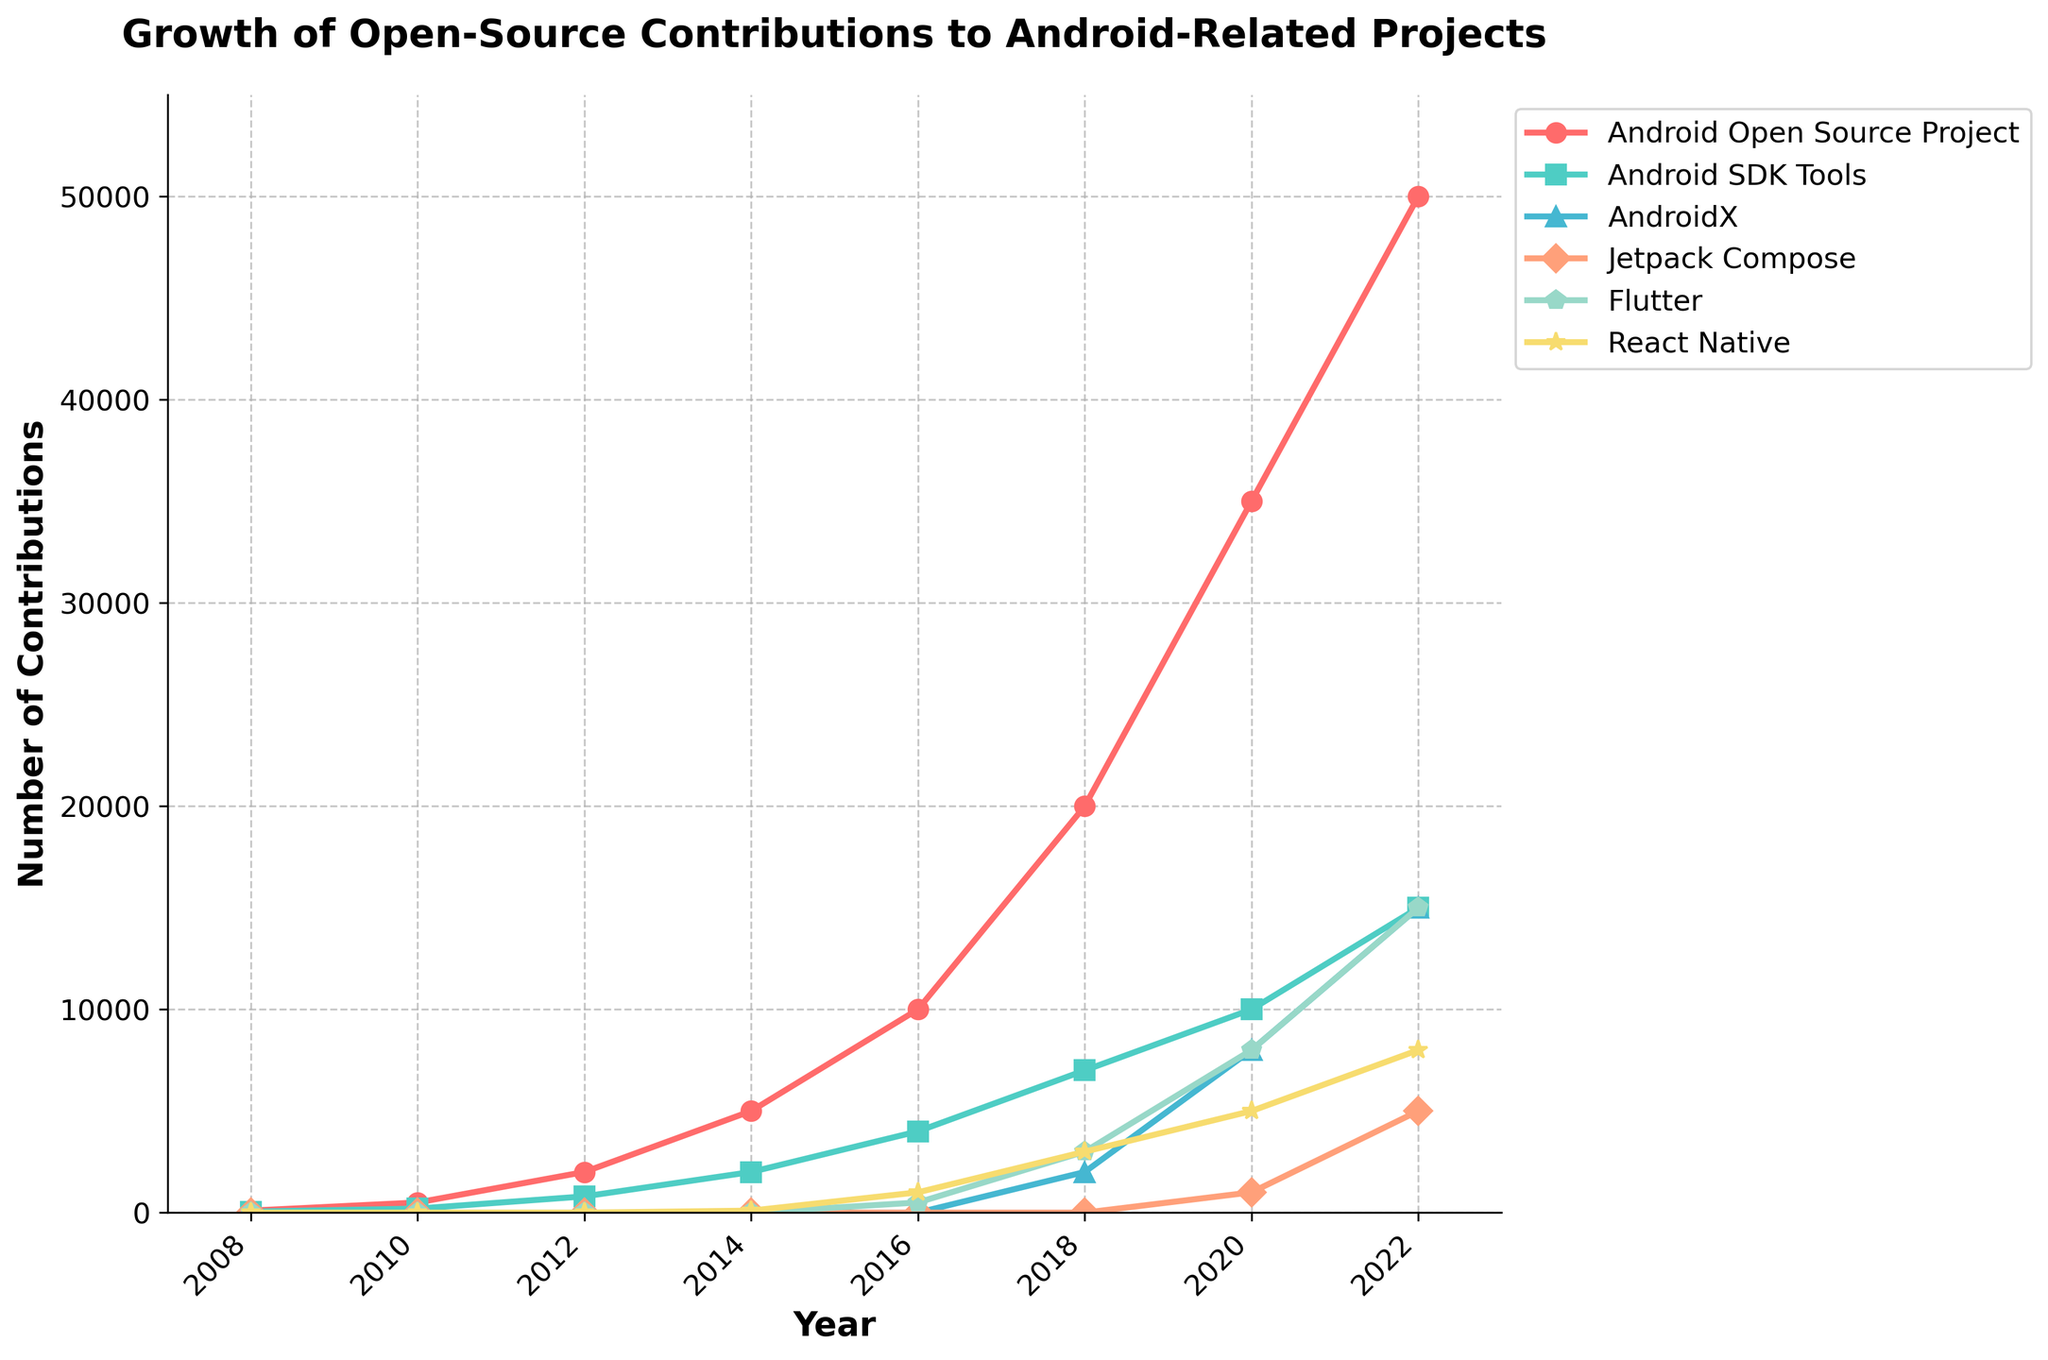Which project had the highest number of contributions in 2022? We look at the year 2022 and compare the contributions across all projects. The highest value belongs to the "Android Open Source Project".
Answer: Android Open Source Project Which project showed the first increase in contributions between 2008 and 2016? From 2008 to 2016, the only project with contributions in 2008 is "Android Open Source Project". By 2010, contributions increased for “Android Open Source Project” and “Android SDK Tools”.
Answer: Android Open Source Project How did the contributions to Jetpack Compose change from 2020 to 2022? In 2020, the contributions to Jetpack Compose were 1000. By 2022, they increased to 5000, which is a difference of 4000 contributions.
Answer: Increased by 4000 Which projects had contributions in 2018 but launched no contributions in 2016? From 2018 we can see contributions for AndroidX starting at 2000, which had no contributions in 2016.
Answer: AndroidX What is the total number of contributions to Flutter and React Native combined in 2020? In 2020, Flutter had 8000 contributions and React Native had 5000. The sum is 8000 + 5000 = 13000.
Answer: 13000 Which project had the steepest growth in contributions from 2018 to 2022? Comparing the contributions from 2018 to 2022, "Android Open Source Project" increased by 30000 (from 20000 to 50000). This is more than any other project.
Answer: Android Open Source Project What is the difference in contributions between Android SDK Tools and AndroidX in 2022? Android SDK Tools had 15000 contributions and AndroidX had 15000 in 2022. The difference is 15000 - 15000 = 0.
Answer: 0 Which project had contributions remain zero up to the year 2022? By looking at the data for each year, all projects have non-zero contributions at various points up to 2022. So none had contributions remaining zero up to 2022.
Answer: None 